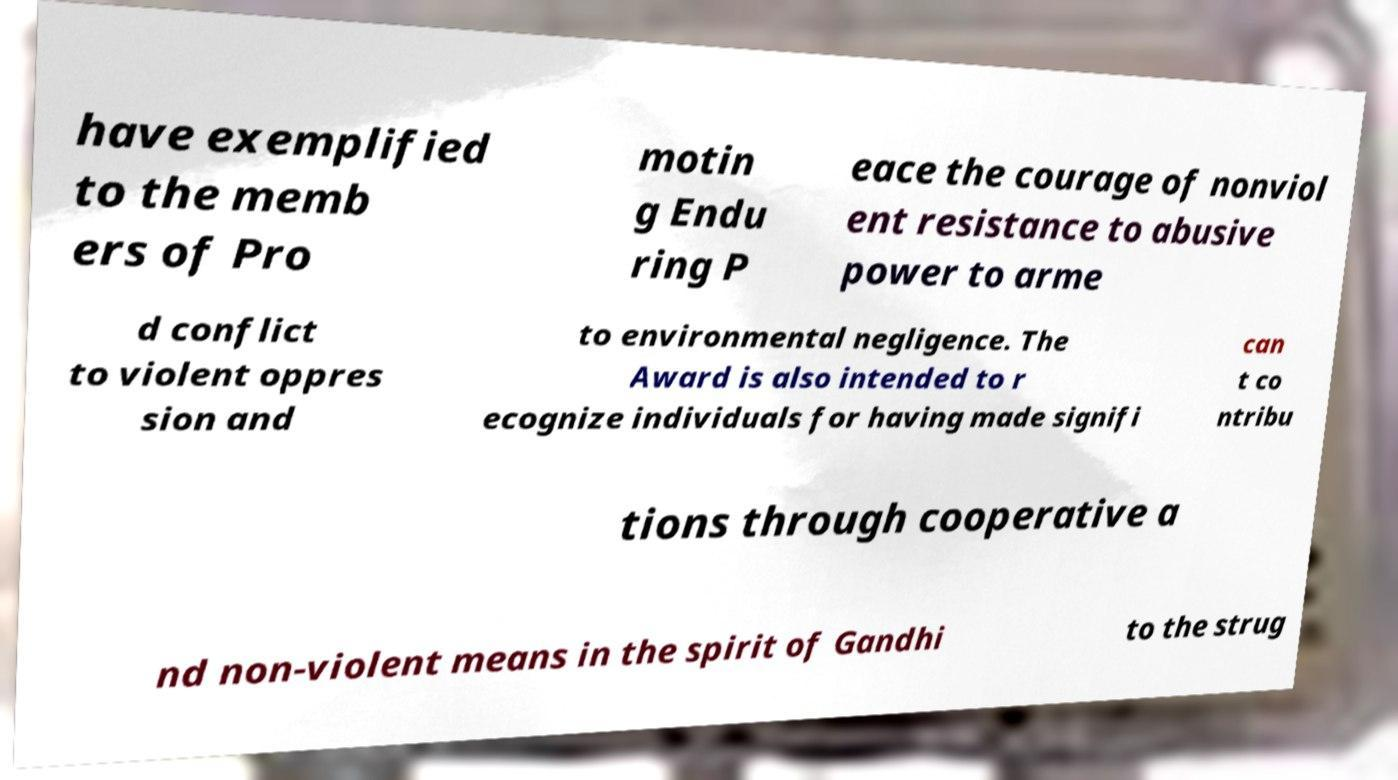Please read and relay the text visible in this image. What does it say? have exemplified to the memb ers of Pro motin g Endu ring P eace the courage of nonviol ent resistance to abusive power to arme d conflict to violent oppres sion and to environmental negligence. The Award is also intended to r ecognize individuals for having made signifi can t co ntribu tions through cooperative a nd non-violent means in the spirit of Gandhi to the strug 